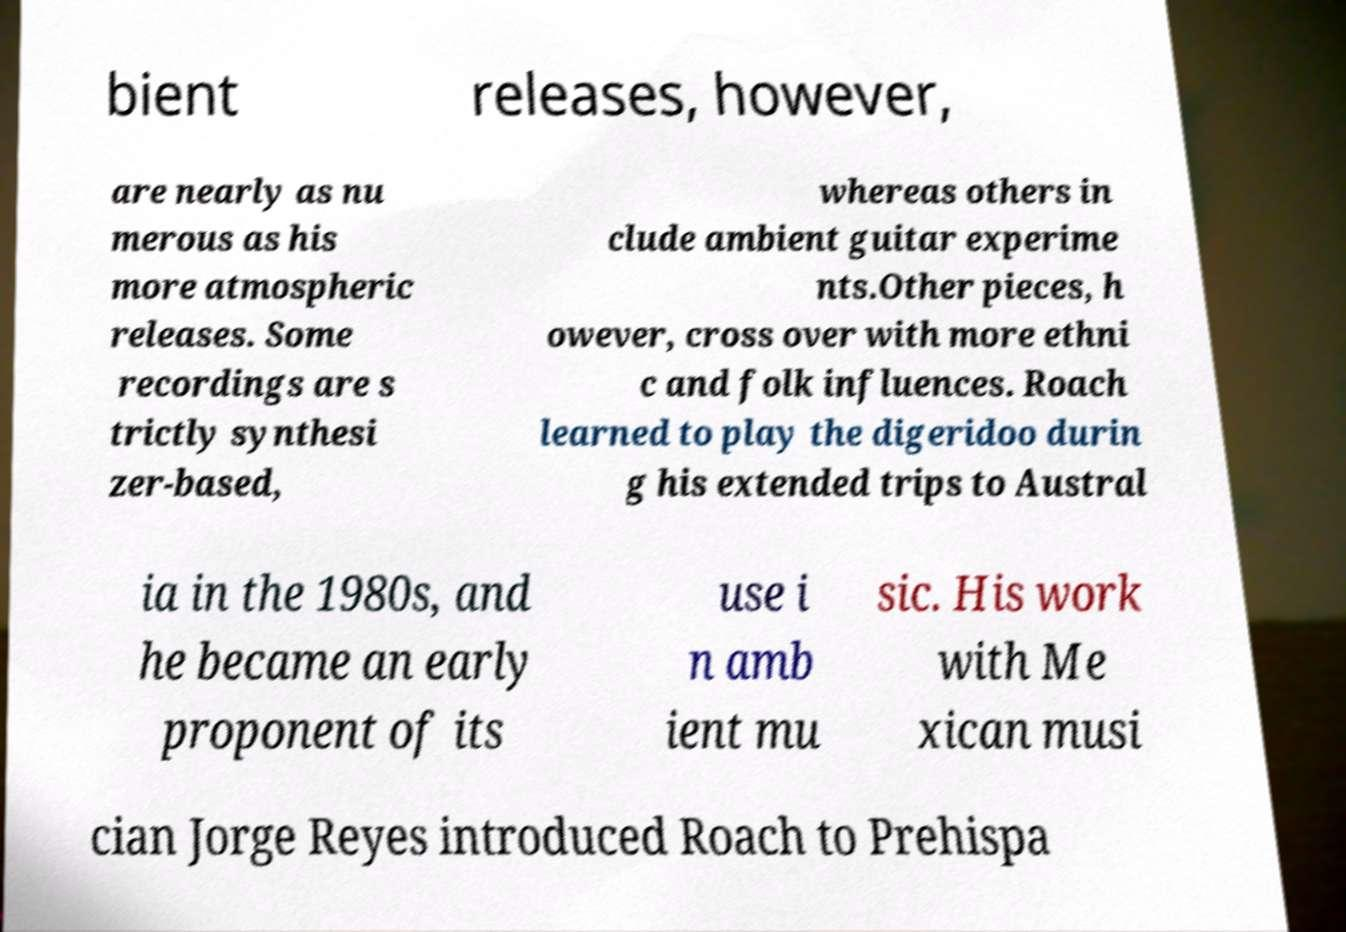For documentation purposes, I need the text within this image transcribed. Could you provide that? bient releases, however, are nearly as nu merous as his more atmospheric releases. Some recordings are s trictly synthesi zer-based, whereas others in clude ambient guitar experime nts.Other pieces, h owever, cross over with more ethni c and folk influences. Roach learned to play the digeridoo durin g his extended trips to Austral ia in the 1980s, and he became an early proponent of its use i n amb ient mu sic. His work with Me xican musi cian Jorge Reyes introduced Roach to Prehispa 